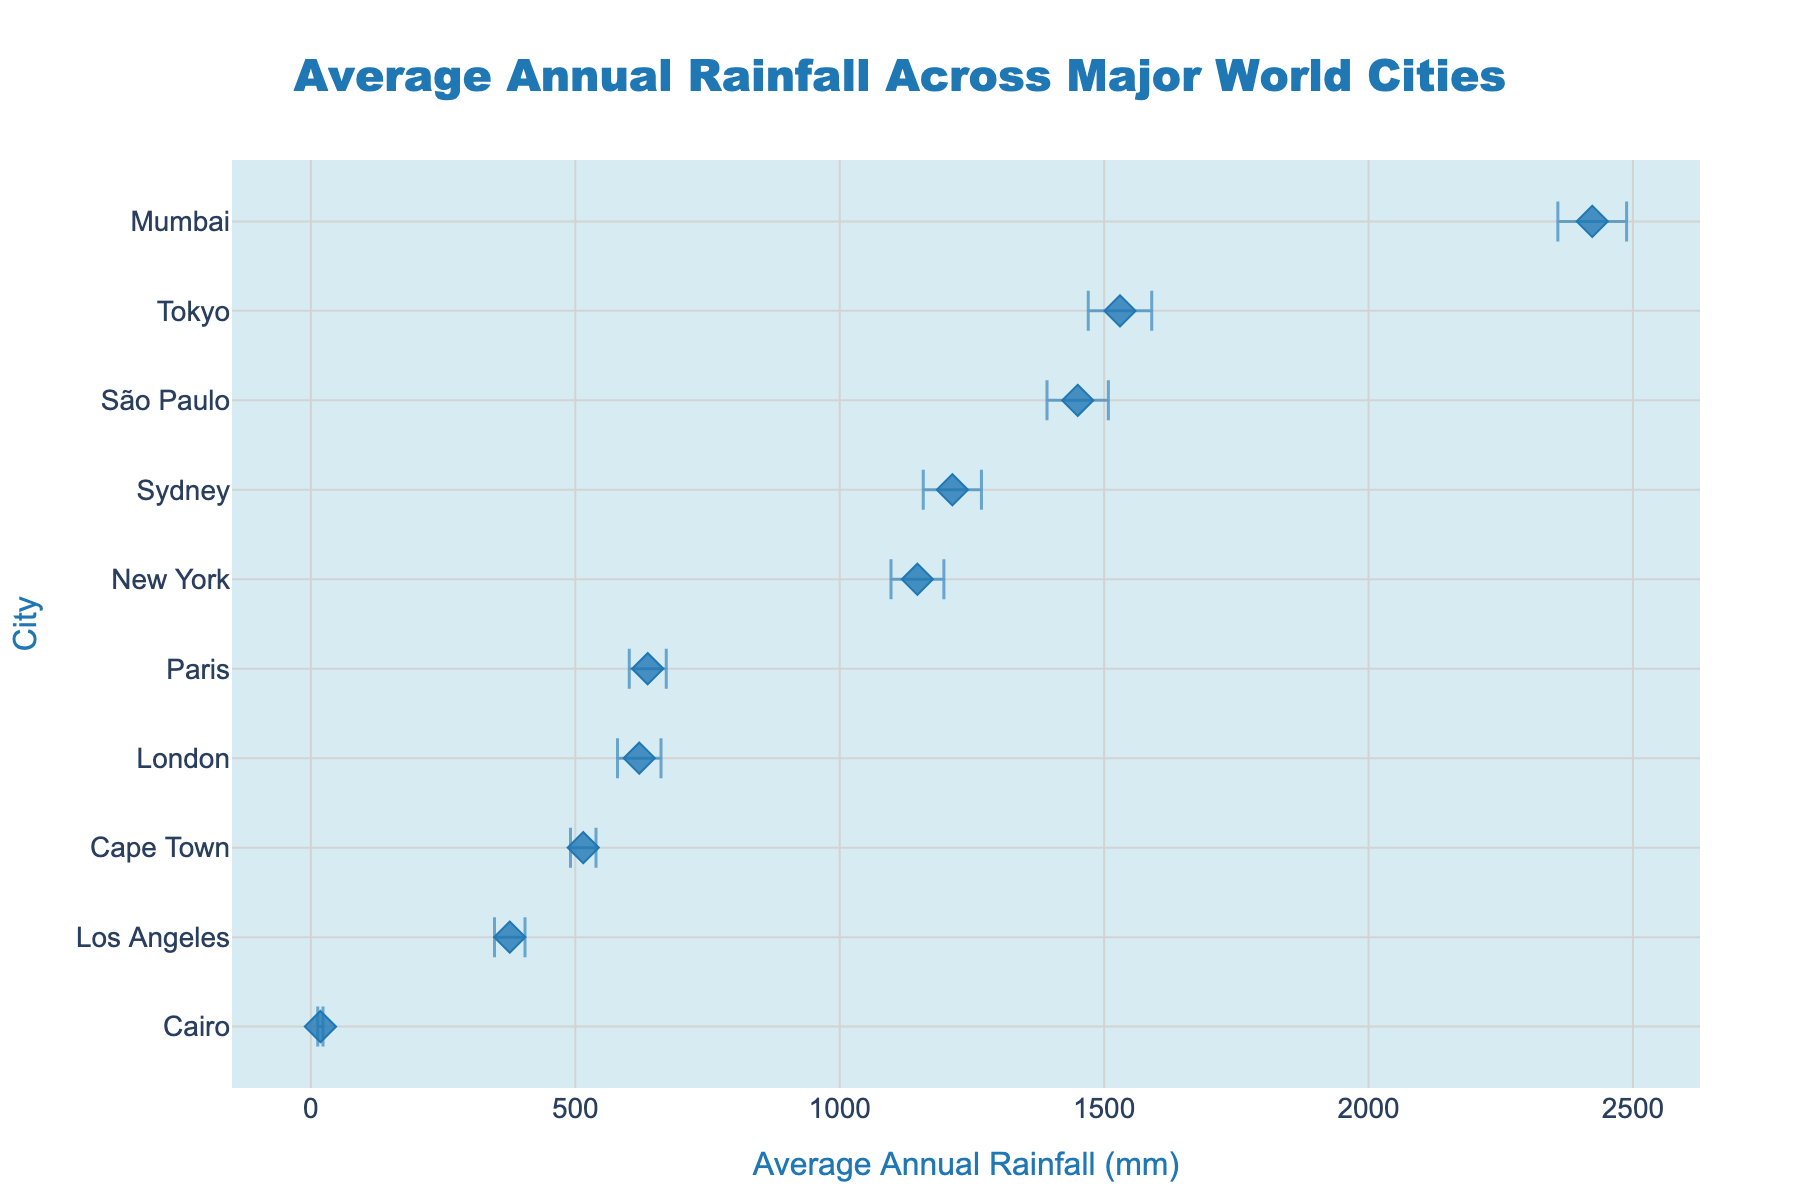Which city has the highest average annual rainfall? The city with the highest average annual rainfall can be identified by finding the data point with the highest value on the x-axis. Here, Mumbai has an average annual rainfall of 2423 mm, which is the highest across all cities.
Answer: Mumbai Which city has the lowest average annual rainfall? By locating the data point with the lowest value on the x-axis, we can find that Cairo has the lowest average annual rainfall at just 18 mm.
Answer: Cairo What is the average annual rainfall in New York? To find the average annual rainfall in New York, we need to locate the New York data point on the plot. The average annual rainfall in New York is shown as 1147 mm.
Answer: 1147 mm How much more rainfall does Tokyo receive compared to London? To determine this, we subtract London's average annual rainfall (621 mm) from Tokyo's (1530 mm). The difference is 1530 mm - 621 mm = 909 mm.
Answer: 909 mm Which city shows the least variability in rainfall? Variability is represented by the size of the error bars. Cairo has the smallest error bar, indicating the least variability with a standard deviation of 5 mm.
Answer: Cairo In which city is the annual rainfall most variable? This can be found by identifying the city with the largest error bar. Mumbai has the highest standard deviation at 65 mm, indicating the most variability.
Answer: Mumbai List the cities where the average annual rainfall is above 1000 mm. By looking at the cities whose data points are to the right of the 1000 mm mark, we identify Tokyo (1530 mm), Sydney (1213 mm), and Mumbai (2423 mm) as having more than 1000 mm of average annual rainfall.
Answer: Tokyo, Sydney, Mumbai What is the range of average annual rainfall values for the cities displayed? The range is calculated by subtracting the minimum value (Cairo, 18 mm) from the maximum value (Mumbai, 2423 mm). The range is 2423 mm - 18 mm = 2405 mm.
Answer: 2405 mm How does the rainfall in Sydney compare to that in São Paulo? To compare, we see that Sydney has 1213 mm of average annual rainfall while São Paulo has 1450 mm. São Paulo receives more rainfall than Sydney.
Answer: São Paulo receives more rainfall than Sydney Rank the cities in ascending order of their average annual rainfall. Once the cities are sorted from the lowest to the highest average annual rainfall, the order is: Cairo, Los Angeles, Cape Town, London, Paris, New York, Sydney, Tokyo, São Paulo, Mumbai.
Answer: Cairo, Los Angeles, Cape Town, London, Paris, New York, Sydney, Tokyo, São Paulo, Mumbai 